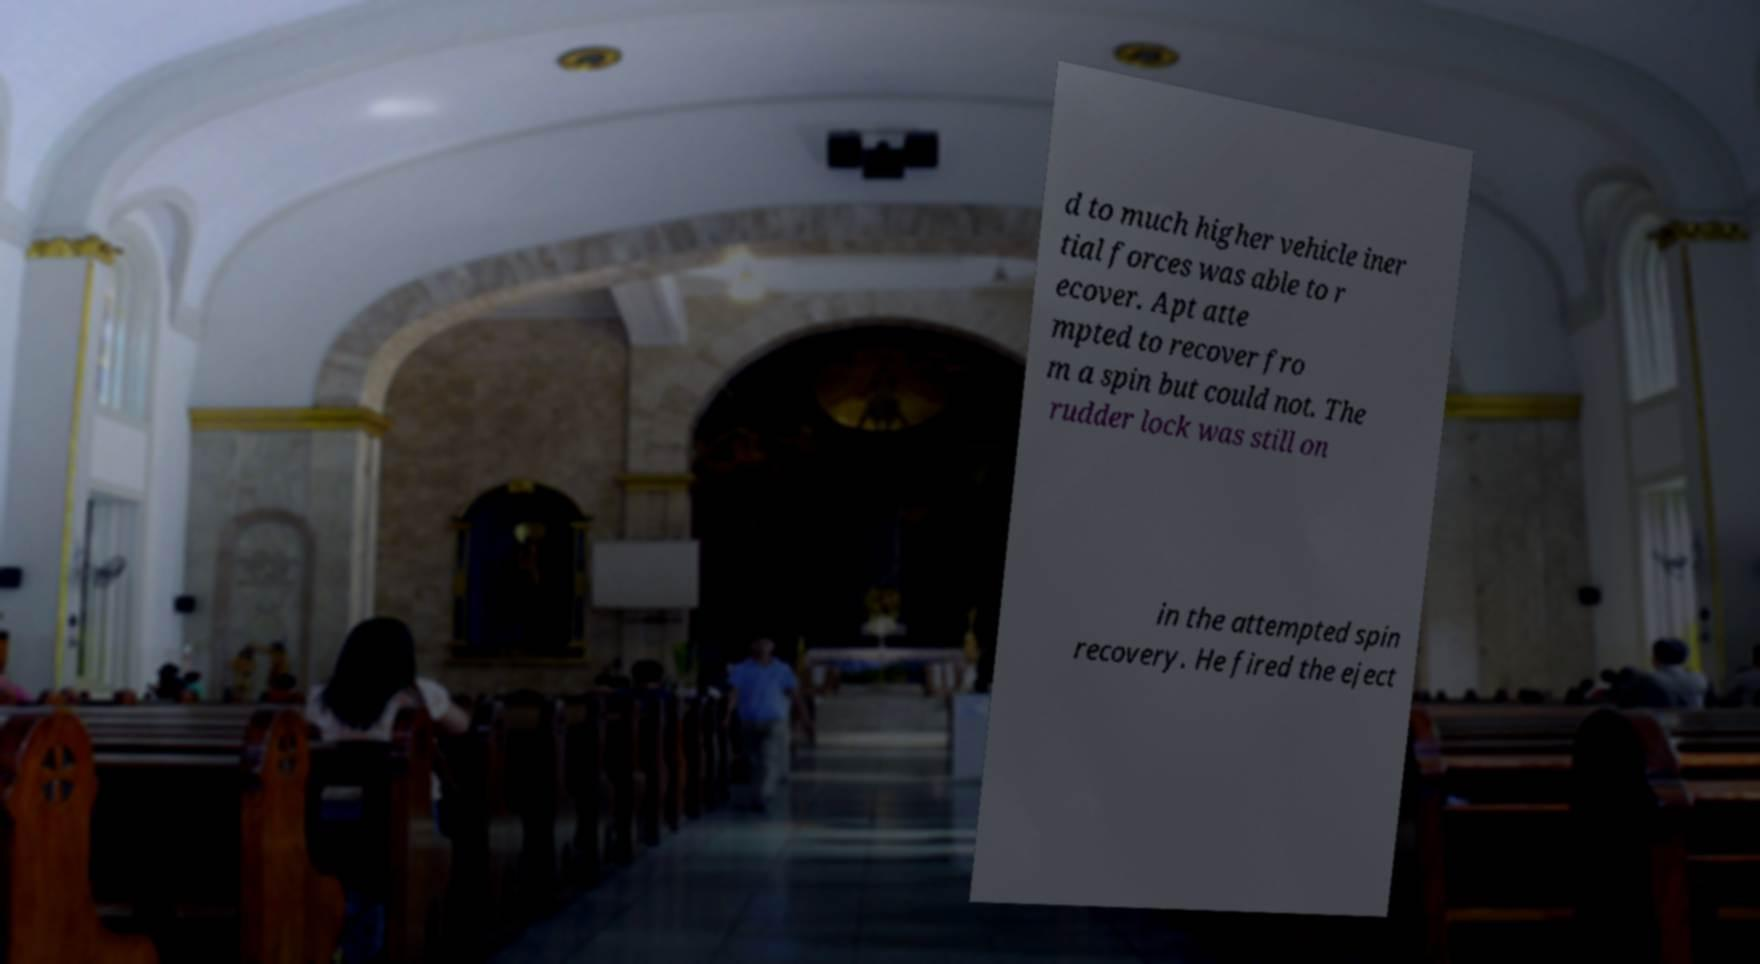Please read and relay the text visible in this image. What does it say? d to much higher vehicle iner tial forces was able to r ecover. Apt atte mpted to recover fro m a spin but could not. The rudder lock was still on in the attempted spin recovery. He fired the eject 